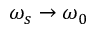Convert formula to latex. <formula><loc_0><loc_0><loc_500><loc_500>\omega _ { s } \rightarrow \omega _ { 0 }</formula> 